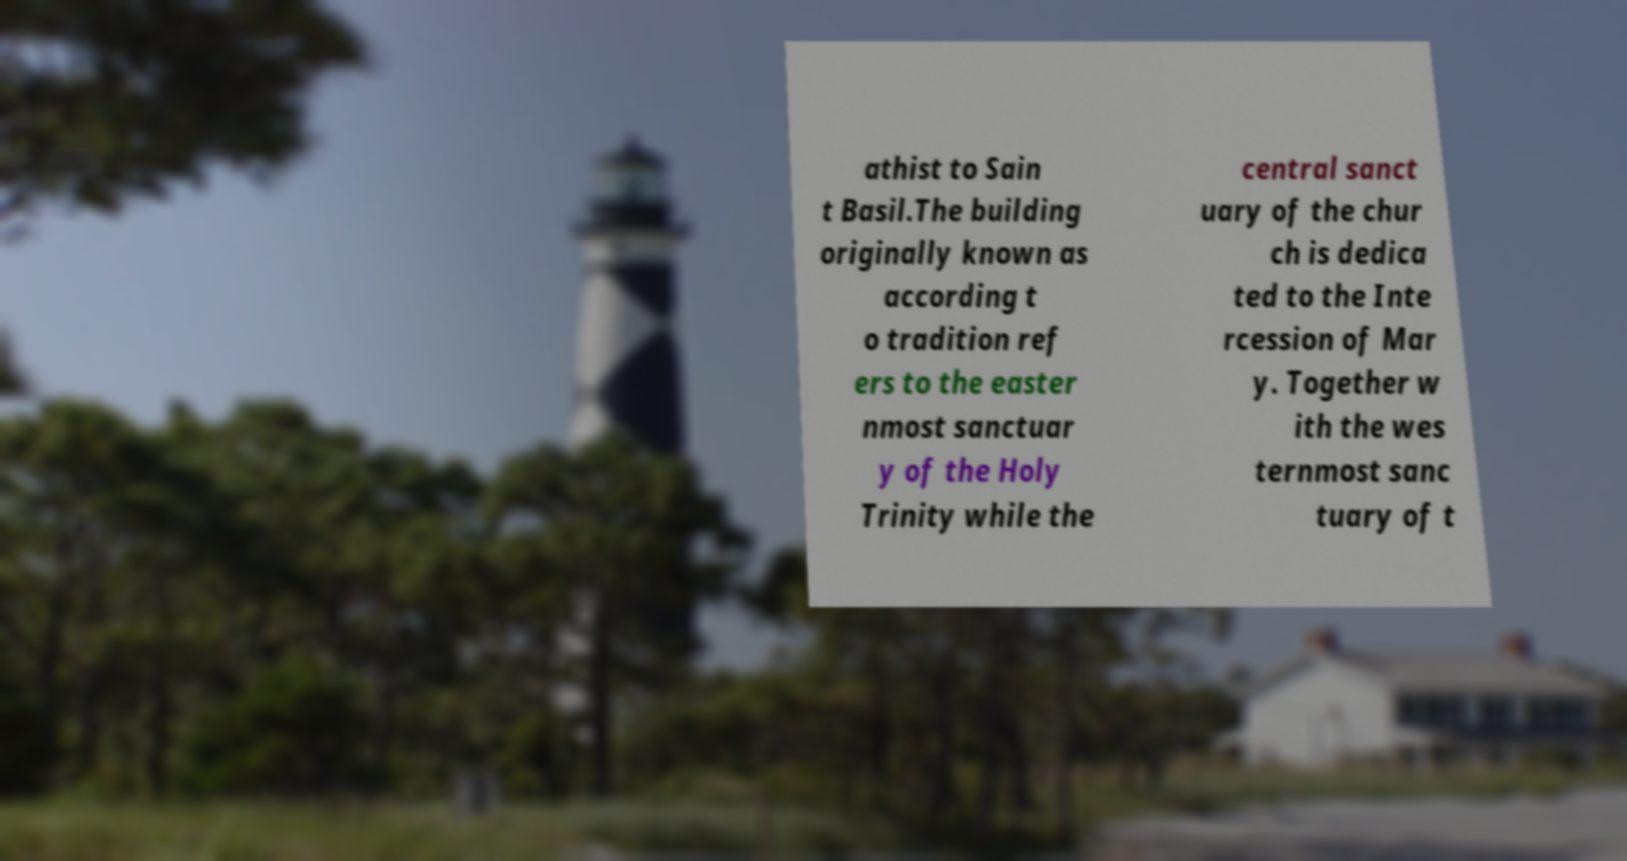Can you read and provide the text displayed in the image?This photo seems to have some interesting text. Can you extract and type it out for me? athist to Sain t Basil.The building originally known as according t o tradition ref ers to the easter nmost sanctuar y of the Holy Trinity while the central sanct uary of the chur ch is dedica ted to the Inte rcession of Mar y. Together w ith the wes ternmost sanc tuary of t 